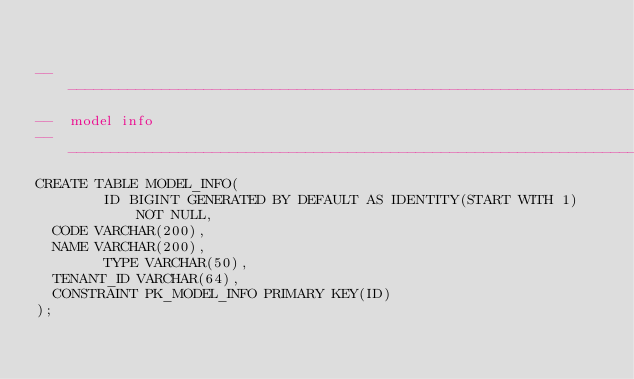Convert code to text. <code><loc_0><loc_0><loc_500><loc_500><_SQL_>

-------------------------------------------------------------------------------
--  model info
-------------------------------------------------------------------------------
CREATE TABLE MODEL_INFO(
        ID BIGINT GENERATED BY DEFAULT AS IDENTITY(START WITH 1) NOT NULL,
	CODE VARCHAR(200),
	NAME VARCHAR(200),
        TYPE VARCHAR(50),
	TENANT_ID VARCHAR(64),
	CONSTRAINT PK_MODEL_INFO PRIMARY KEY(ID)
);

</code> 